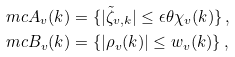<formula> <loc_0><loc_0><loc_500><loc_500>\ m c A _ { v } ( k ) & = \{ | \tilde { \zeta } _ { v , k } | \leq \epsilon \theta \chi _ { v } ( k ) \} \, , \\ \ m c B _ { v } ( k ) & = \{ | \rho _ { v } ( k ) | \leq w _ { v } ( k ) \} \, ,</formula> 